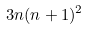Convert formula to latex. <formula><loc_0><loc_0><loc_500><loc_500>3 n ( n + 1 ) ^ { 2 }</formula> 